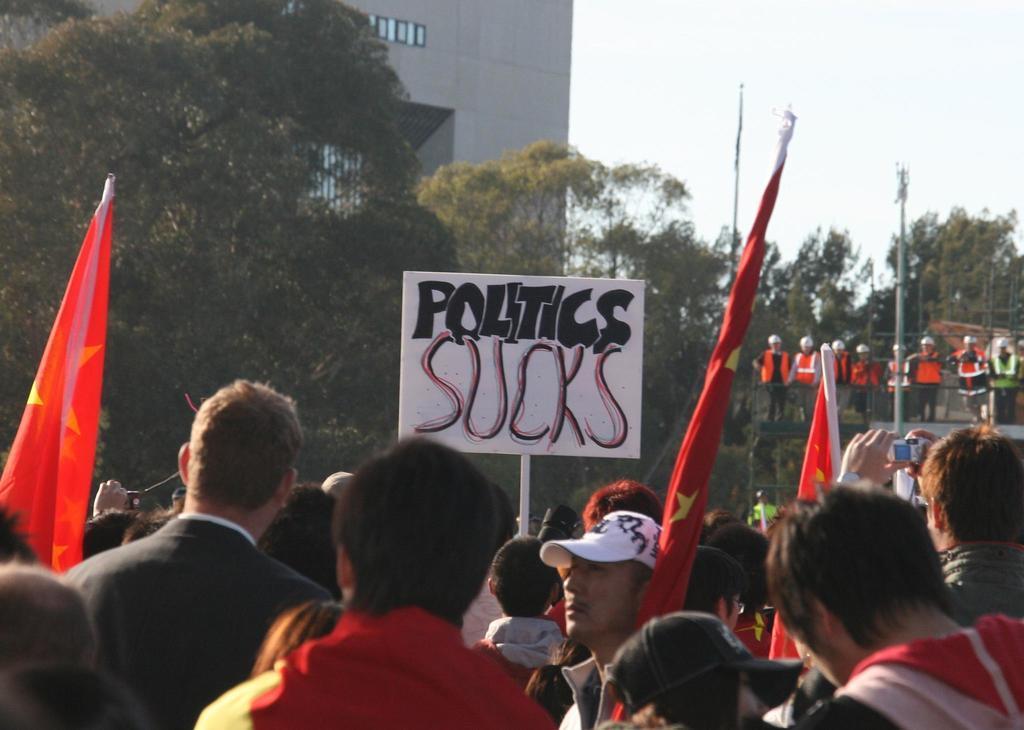Please provide a concise description of this image. In this image at the bottom there are few people visible, few of them are holding flags, poles, on which there is a board, on the board there is a text, in the middle there is a building trees visible, on the right side there is the sky, trees, poles, people. 